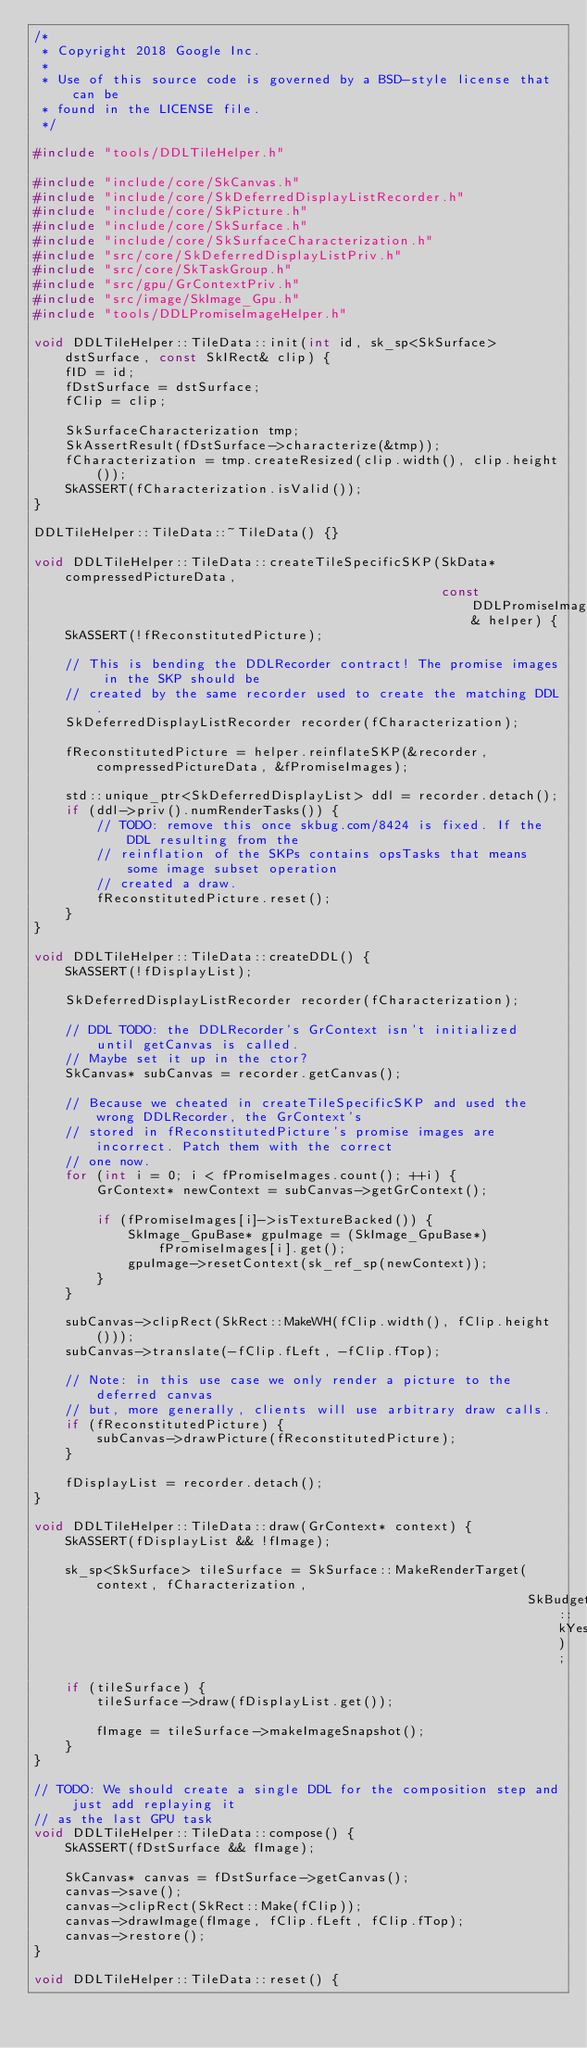Convert code to text. <code><loc_0><loc_0><loc_500><loc_500><_C++_>/*
 * Copyright 2018 Google Inc.
 *
 * Use of this source code is governed by a BSD-style license that can be
 * found in the LICENSE file.
 */

#include "tools/DDLTileHelper.h"

#include "include/core/SkCanvas.h"
#include "include/core/SkDeferredDisplayListRecorder.h"
#include "include/core/SkPicture.h"
#include "include/core/SkSurface.h"
#include "include/core/SkSurfaceCharacterization.h"
#include "src/core/SkDeferredDisplayListPriv.h"
#include "src/core/SkTaskGroup.h"
#include "src/gpu/GrContextPriv.h"
#include "src/image/SkImage_Gpu.h"
#include "tools/DDLPromiseImageHelper.h"

void DDLTileHelper::TileData::init(int id, sk_sp<SkSurface> dstSurface, const SkIRect& clip) {
    fID = id;
    fDstSurface = dstSurface;
    fClip = clip;

    SkSurfaceCharacterization tmp;
    SkAssertResult(fDstSurface->characterize(&tmp));
    fCharacterization = tmp.createResized(clip.width(), clip.height());
    SkASSERT(fCharacterization.isValid());
}

DDLTileHelper::TileData::~TileData() {}

void DDLTileHelper::TileData::createTileSpecificSKP(SkData* compressedPictureData,
                                                    const DDLPromiseImageHelper& helper) {
    SkASSERT(!fReconstitutedPicture);

    // This is bending the DDLRecorder contract! The promise images in the SKP should be
    // created by the same recorder used to create the matching DDL.
    SkDeferredDisplayListRecorder recorder(fCharacterization);

    fReconstitutedPicture = helper.reinflateSKP(&recorder, compressedPictureData, &fPromiseImages);

    std::unique_ptr<SkDeferredDisplayList> ddl = recorder.detach();
    if (ddl->priv().numRenderTasks()) {
        // TODO: remove this once skbug.com/8424 is fixed. If the DDL resulting from the
        // reinflation of the SKPs contains opsTasks that means some image subset operation
        // created a draw.
        fReconstitutedPicture.reset();
    }
}

void DDLTileHelper::TileData::createDDL() {
    SkASSERT(!fDisplayList);

    SkDeferredDisplayListRecorder recorder(fCharacterization);

    // DDL TODO: the DDLRecorder's GrContext isn't initialized until getCanvas is called.
    // Maybe set it up in the ctor?
    SkCanvas* subCanvas = recorder.getCanvas();

    // Because we cheated in createTileSpecificSKP and used the wrong DDLRecorder, the GrContext's
    // stored in fReconstitutedPicture's promise images are incorrect. Patch them with the correct
    // one now.
    for (int i = 0; i < fPromiseImages.count(); ++i) {
        GrContext* newContext = subCanvas->getGrContext();

        if (fPromiseImages[i]->isTextureBacked()) {
            SkImage_GpuBase* gpuImage = (SkImage_GpuBase*) fPromiseImages[i].get();
            gpuImage->resetContext(sk_ref_sp(newContext));
        }
    }

    subCanvas->clipRect(SkRect::MakeWH(fClip.width(), fClip.height()));
    subCanvas->translate(-fClip.fLeft, -fClip.fTop);

    // Note: in this use case we only render a picture to the deferred canvas
    // but, more generally, clients will use arbitrary draw calls.
    if (fReconstitutedPicture) {
        subCanvas->drawPicture(fReconstitutedPicture);
    }

    fDisplayList = recorder.detach();
}

void DDLTileHelper::TileData::draw(GrContext* context) {
    SkASSERT(fDisplayList && !fImage);

    sk_sp<SkSurface> tileSurface = SkSurface::MakeRenderTarget(context, fCharacterization,
                                                               SkBudgeted::kYes);
    if (tileSurface) {
        tileSurface->draw(fDisplayList.get());

        fImage = tileSurface->makeImageSnapshot();
    }
}

// TODO: We should create a single DDL for the composition step and just add replaying it
// as the last GPU task
void DDLTileHelper::TileData::compose() {
    SkASSERT(fDstSurface && fImage);

    SkCanvas* canvas = fDstSurface->getCanvas();
    canvas->save();
    canvas->clipRect(SkRect::Make(fClip));
    canvas->drawImage(fImage, fClip.fLeft, fClip.fTop);
    canvas->restore();
}

void DDLTileHelper::TileData::reset() {</code> 